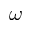<formula> <loc_0><loc_0><loc_500><loc_500>\omega</formula> 